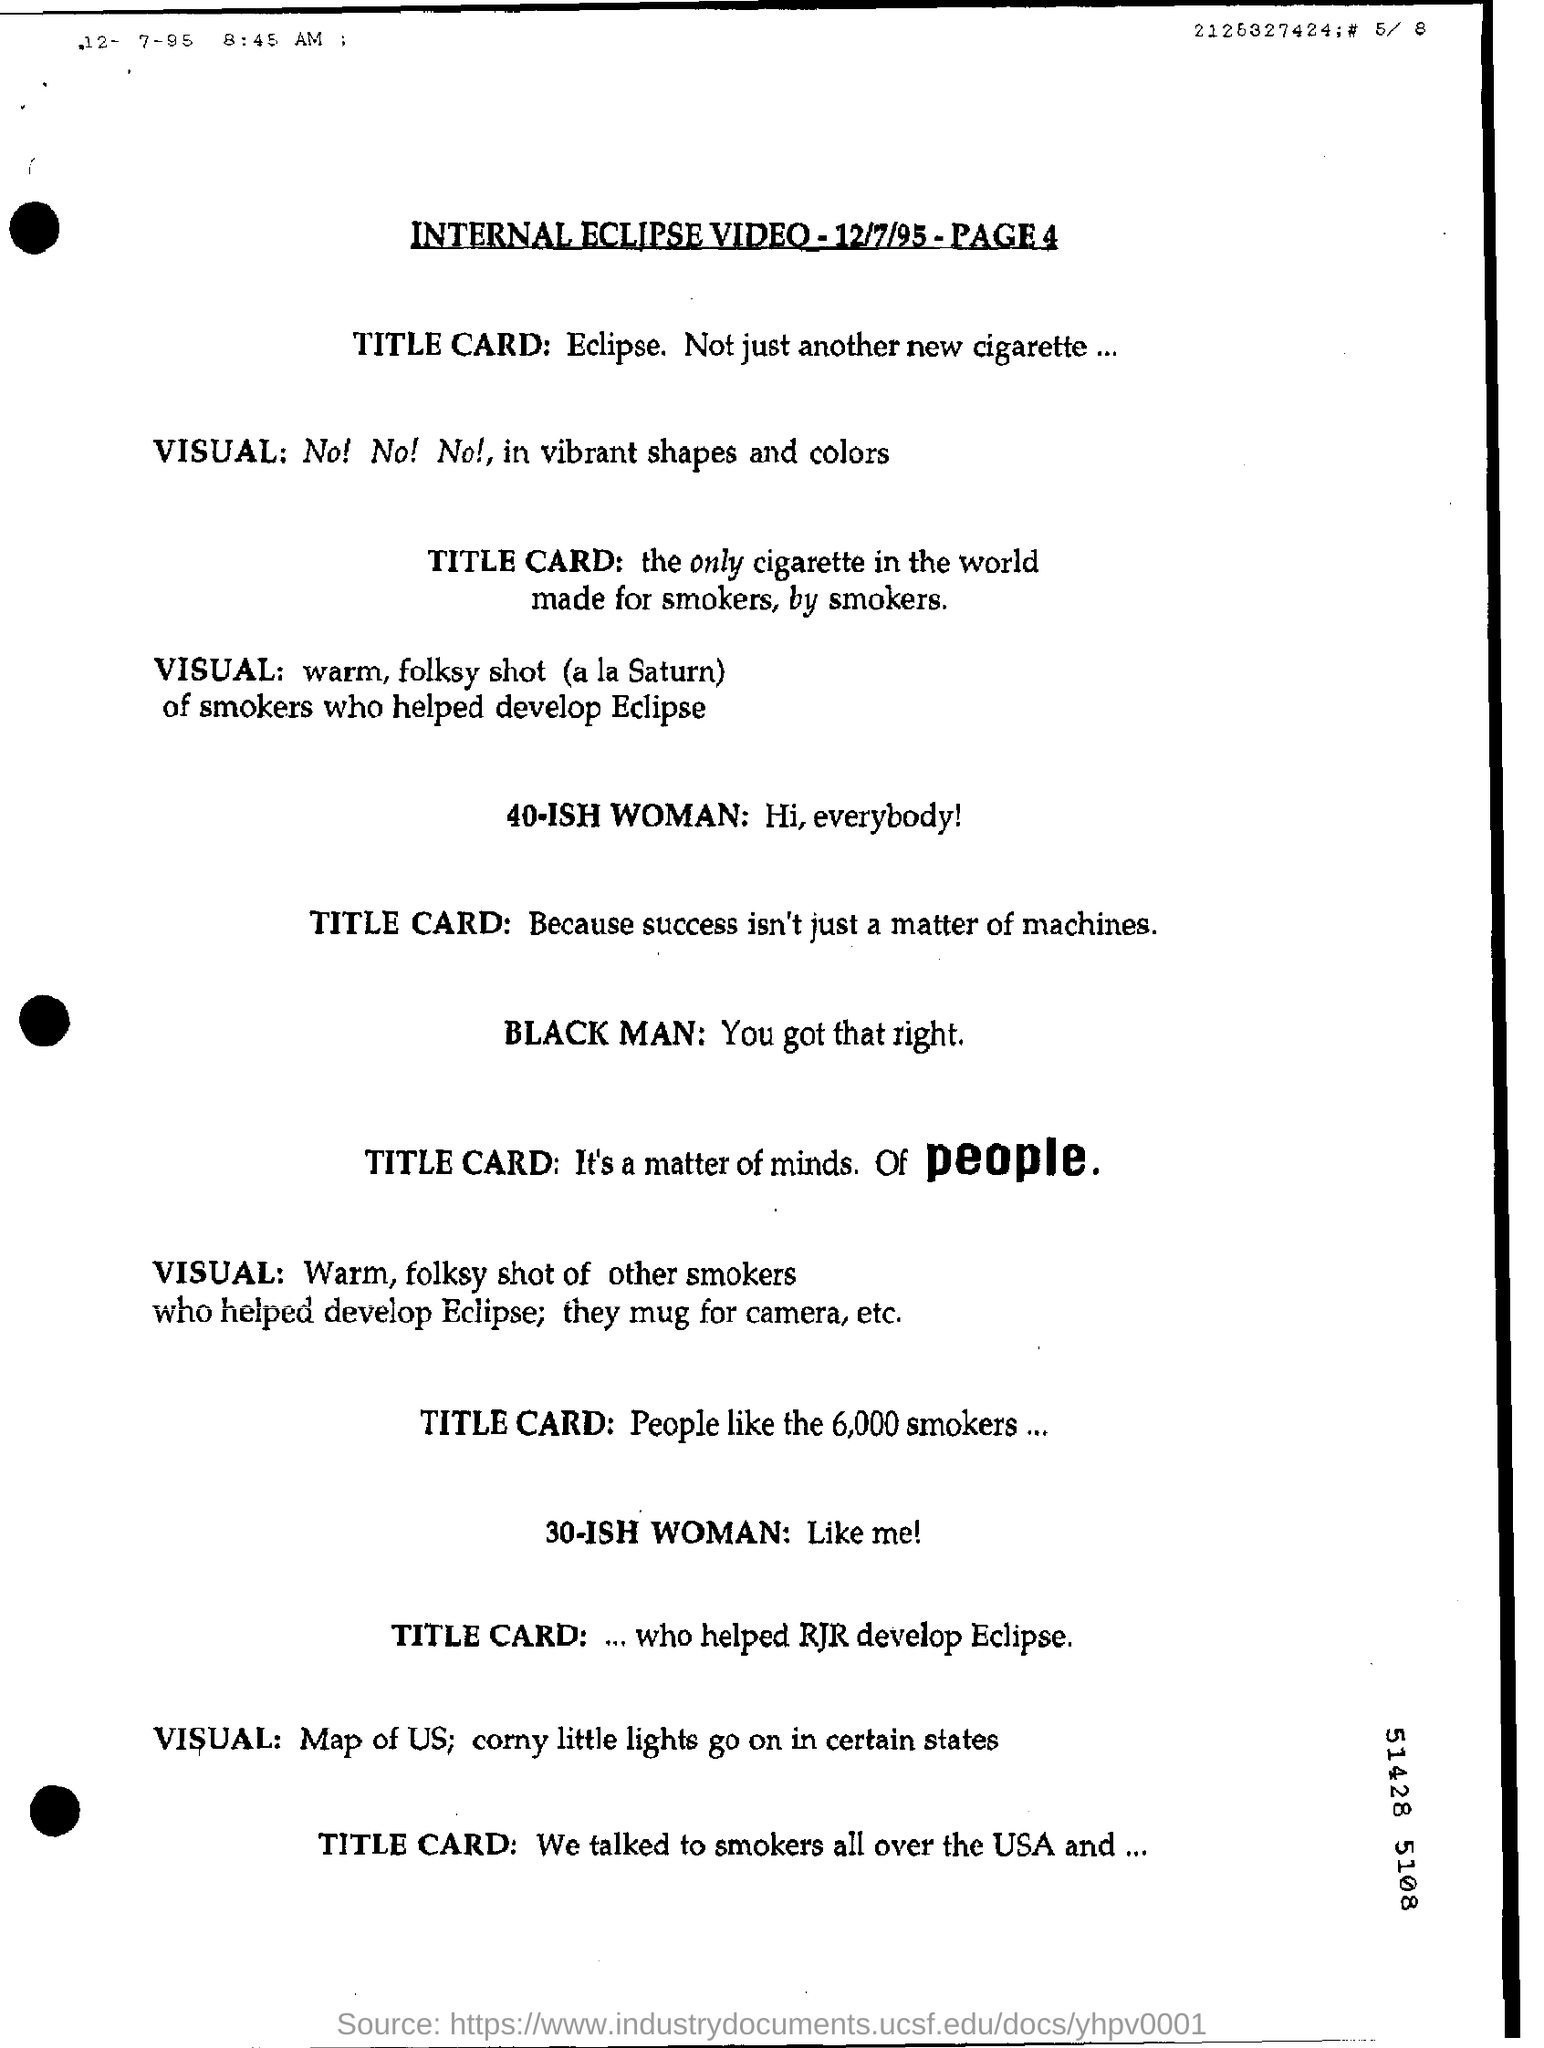What is the name of new cigarette brand?
Give a very brief answer. Eclipse. 